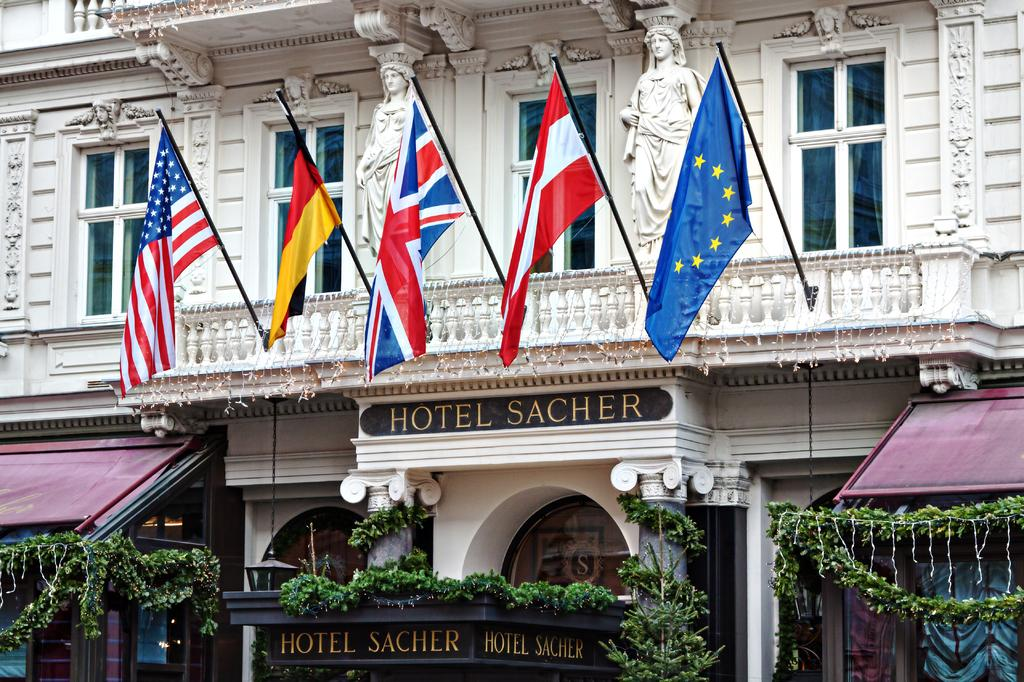What is located in the center of the image? There are flags in the center of the image. Where are the flags attached? The flags are attached to a building. What can be seen at the bottom of the image? There are plants and tents at the bottom of the image. What is the name board used for in the image? The name board is used to identify the location or event at the bottom of the image. How many people are present in the aftermath of the event in the image? There is no mention of an event or aftermath in the image, and no crowd is visible. Can you see a cat playing with the flags in the image? There is no cat present in the image; only flags, a building, plants, tents, and a name board are visible. 